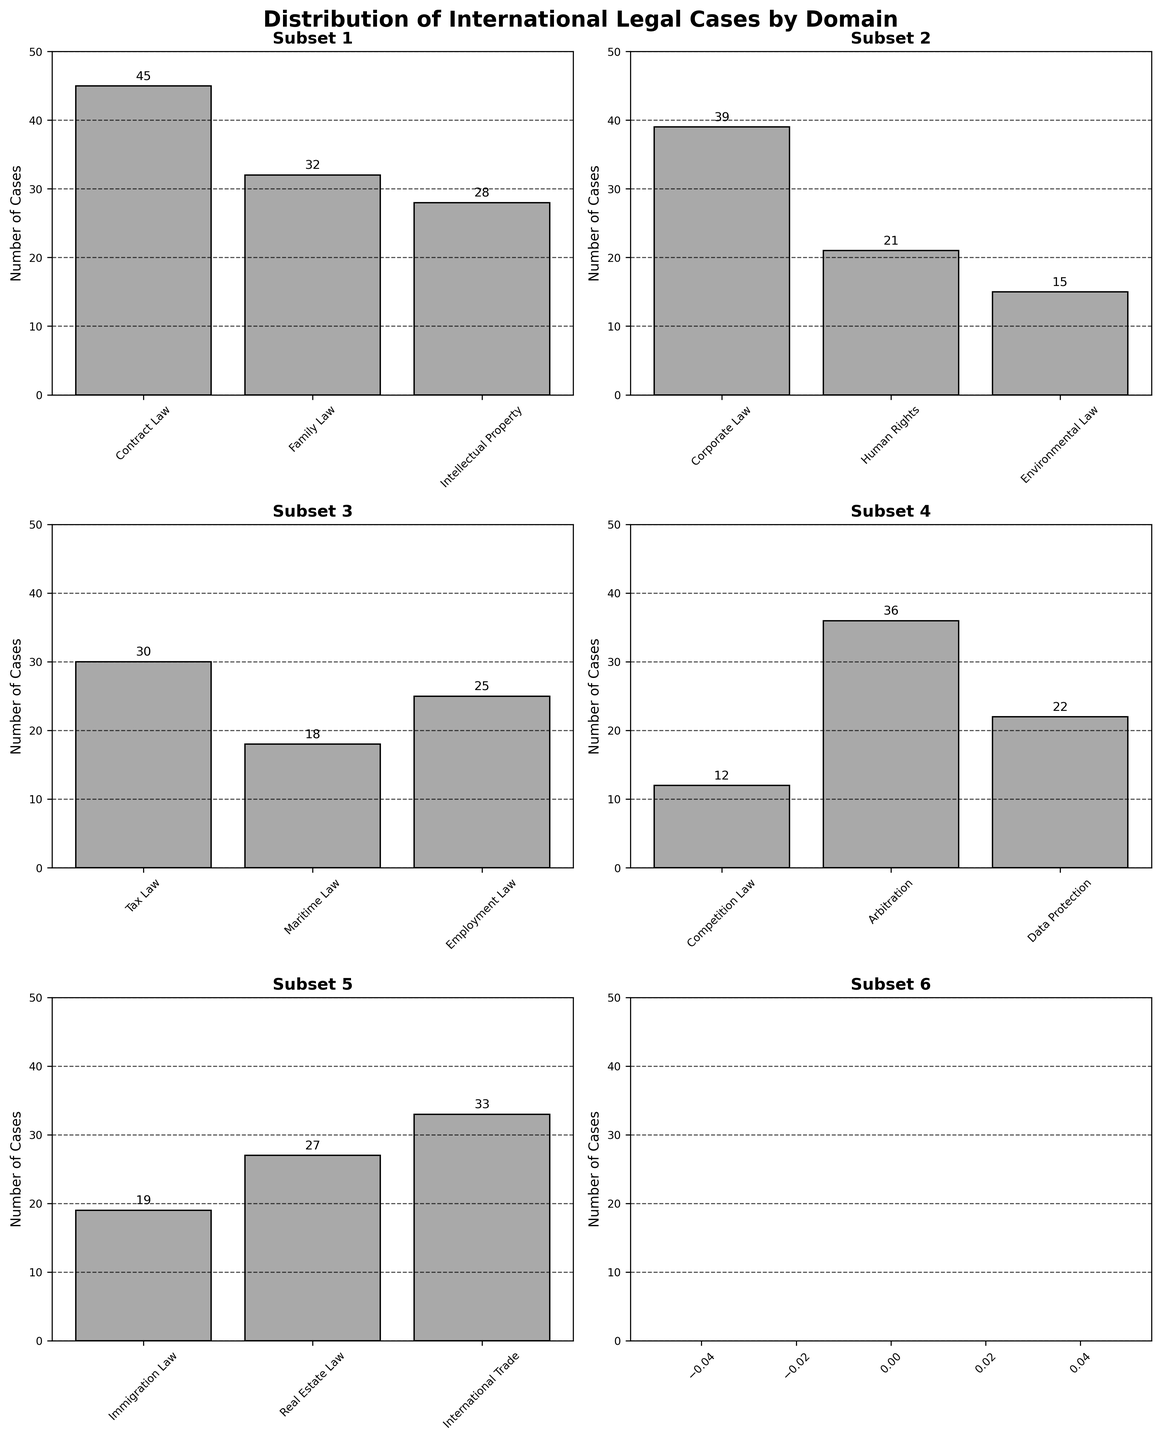How many legal domains are shown in the figure? The figure is divided into multiple subplots, each showing a subset of legal domains. Counting the total number of unique domains across all subplots, we get 15 domains.
Answer: 15 What is the title of the entire figure? The title of the figure is displayed prominently at the top, stating "Distribution of International Legal Cases by Domain."
Answer: Distribution of International Legal Cases by Domain Which subset contains the domain with the highest number of cases? By examining all the subplots, we find that Contract Law, with 45 cases, is the domain with the highest number of cases, and it is shown in the first subset.
Answer: Subset 1 How many cases are there in total for Arbitration, Competition Law, and Corporate Law combined? Arbitration has 36 cases, Competition Law has 12 cases, and Corporate Law has 39 cases. Summing them up: 36 + 12 + 39 = 87.
Answer: 87 Which subset shows the domain with the fewest cases? By checking all subplots, Competition Law with 12 cases is the domain with the fewest cases, which appears in the fourth subset.
Answer: Subset 4 What is the median number of cases across all legal domains? To find the median, list the number of cases in ascending order: 12, 15, 18, 19, 21, 22, 25, 27, 28, 30, 32, 33, 36, 39, 45. The middle value in this sorted list is 27.
Answer: 27 Between Family Law and Environmental Law, which has more cases and by how much? Family Law has 32 cases while Environmental Law has 15 cases. The difference is 32 - 15 = 17 cases.
Answer: Family Law by 17 cases How many cases are shown in Subset 2 in total? The second subset contains Family Law (32), Intellectual Property (28), and Corporate Law (39). Summing them: 32 + 28 + 39 = 99.
Answer: 99 Which domain has fewer cases: Employment Law or Immigration Law? Employment Law has 25 cases, while Immigration Law has 19 cases. Thus, Immigration Law has fewer cases.
Answer: Immigration Law Is the number of cases in Real Estate Law higher or lower than in Data Protection? Real Estate Law has 27 cases, whereas Data Protection has 22 cases. Therefore, Real Estate Law has a higher number of cases.
Answer: Higher 